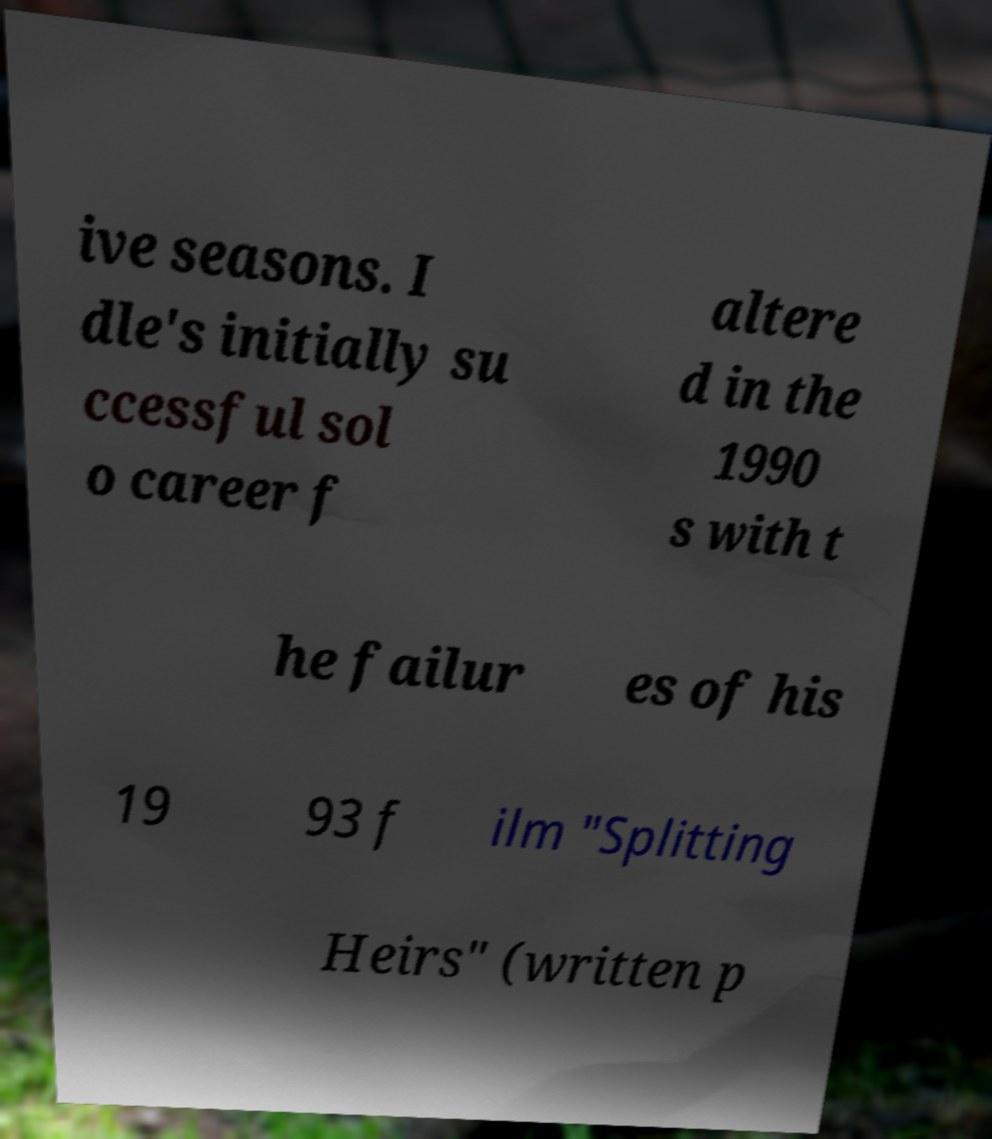Could you extract and type out the text from this image? ive seasons. I dle's initially su ccessful sol o career f altere d in the 1990 s with t he failur es of his 19 93 f ilm "Splitting Heirs" (written p 